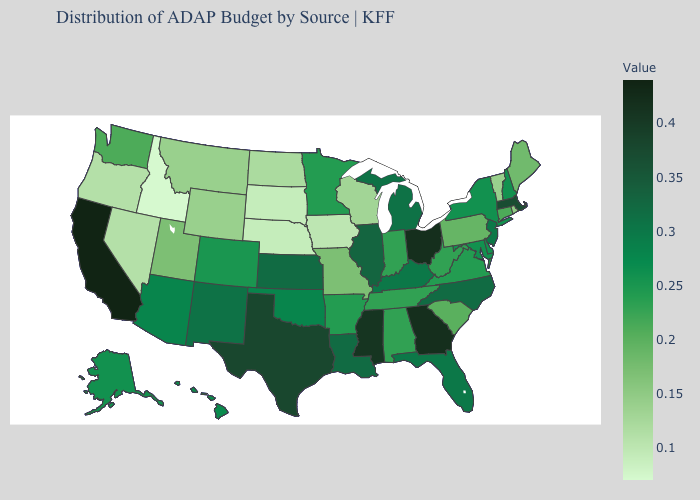Among the states that border Delaware , which have the lowest value?
Short answer required. Pennsylvania. Which states have the lowest value in the West?
Short answer required. Idaho. Among the states that border Vermont , which have the highest value?
Give a very brief answer. Massachusetts. Is the legend a continuous bar?
Answer briefly. Yes. Which states have the lowest value in the Northeast?
Quick response, please. Vermont. Which states hav the highest value in the South?
Answer briefly. Georgia. Is the legend a continuous bar?
Keep it brief. Yes. 